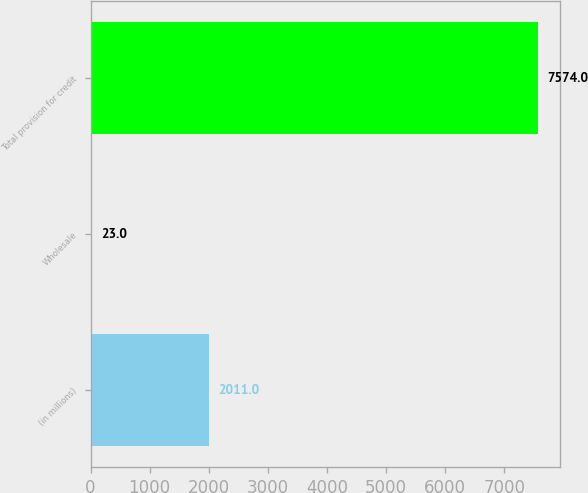Convert chart. <chart><loc_0><loc_0><loc_500><loc_500><bar_chart><fcel>(in millions)<fcel>Wholesale<fcel>Total provision for credit<nl><fcel>2011<fcel>23<fcel>7574<nl></chart> 